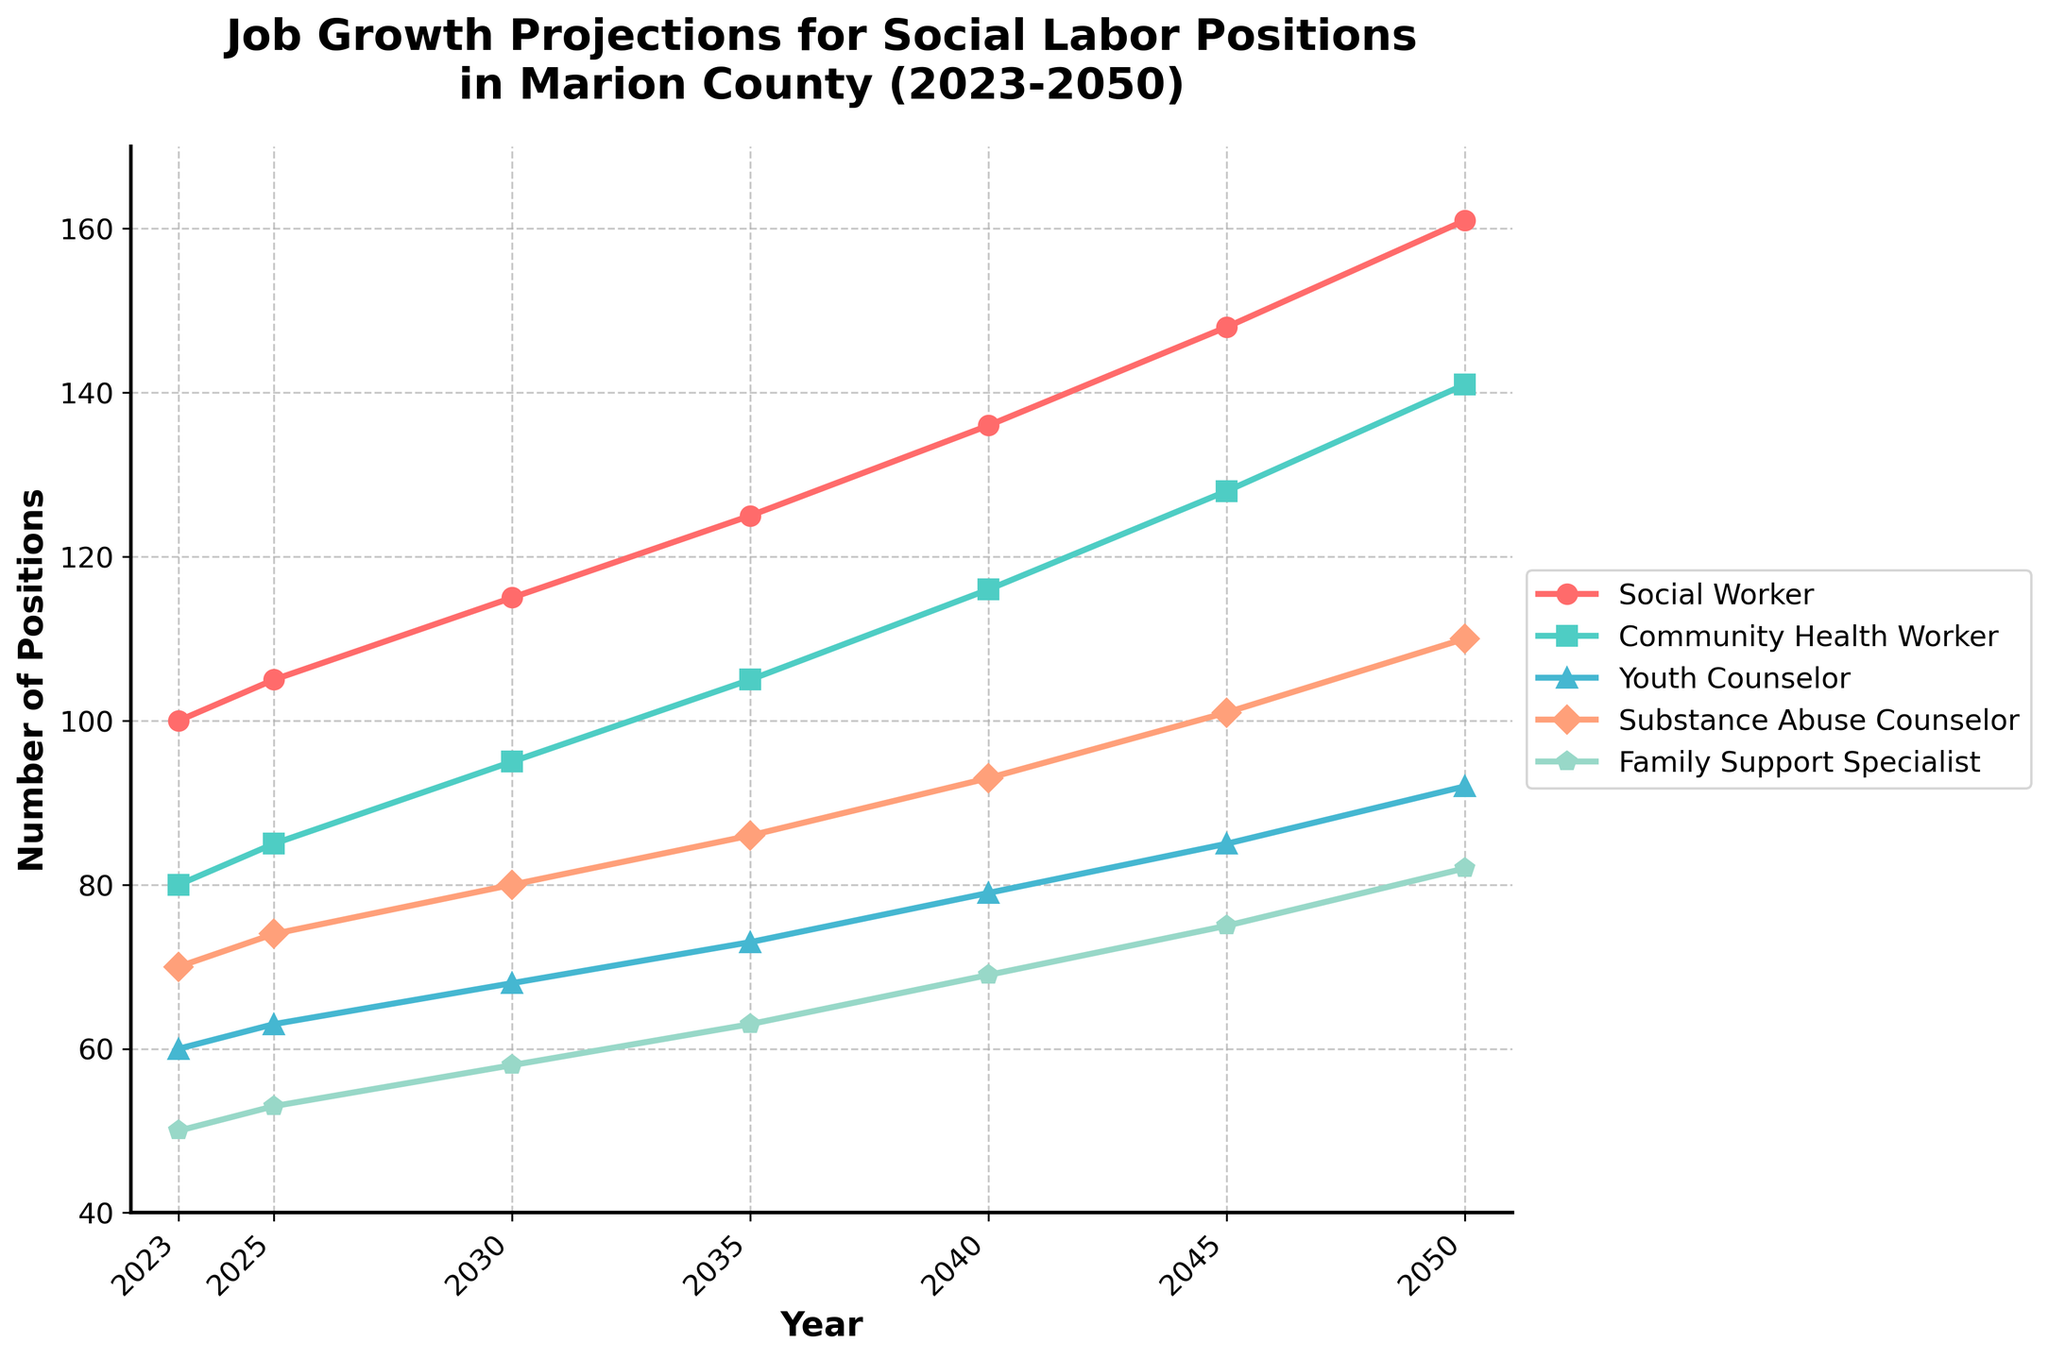Which role is projected to have the highest number of positions by 2050? By looking at the plot, we can identify that the 'Social Worker' role has the highest point on the y-axis for the year 2050.
Answer: Social Worker Between which years does the 'Family Support Specialist' see the most significant increase in positions? By comparing the y-axis values for the 'Family Support Specialist' line, the sharpest increase is between 2045 and 2050, where it rises from 75 to 82.
Answer: 2045-2050 What is the difference in the number of 'Youth Counselor' positions between 2030 and 2045? The 'Youth Counselor' positions in 2030 are 68 and in 2045 are 85. The difference is 85 - 68 = 17.
Answer: 17 During which decade is the growth rate for 'Community Health Worker' the highest? By finding the slope of the 'Community Health Worker' line between decades, from 2023 to 2030, it grows from 80 to 95 (15 positions), while from 2040 to 2050, it grows from 116 to 141 (25 positions). Thus, the highest growth is from 2040 to 2050.
Answer: 2040-2050 What is the combined number of 'Substance Abuse Counselor' and 'Family Support Specialist' positions in 2035? The 'Substance Abuse Counselor' positions in 2035 are 86, and the 'Family Support Specialist' positions in 2035 are 63. The combined total is 86 + 63 = 149.
Answer: 149 Which role shows a continuous upward trend with no declines from 2023 to 2050? By observing all the lines, 'Social Worker', 'Community Health Worker', 'Youth Counselor', 'Substance Abuse Counselor', and 'Family Support Specialist' all show continuous upward trends.
Answer: All roles What is the average number of 'Social Worker' positions between 2025 and 2045? The 'Social Worker' positions are 105 (2025), 125 (2035), and 148 (2045). Their average is (105 + 125 + 148) / 3 = 126.
Answer: 126 In which year does the 'Youth Counselor' role first surpass 70 positions? By following the 'Youth Counselor' line, it surpasses 70 positions first in the year 2035.
Answer: 2035 